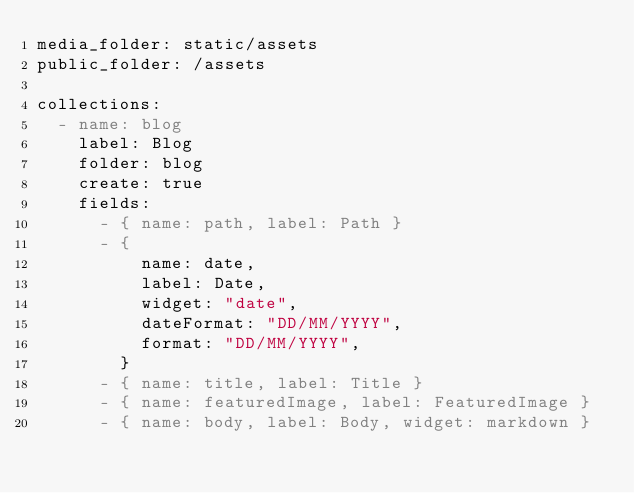<code> <loc_0><loc_0><loc_500><loc_500><_YAML_>media_folder: static/assets
public_folder: /assets

collections:
  - name: blog
    label: Blog
    folder: blog
    create: true
    fields:
      - { name: path, label: Path }
      - {
          name: date,
          label: Date,
          widget: "date",
          dateFormat: "DD/MM/YYYY",
          format: "DD/MM/YYYY",
        }
      - { name: title, label: Title }
      - { name: featuredImage, label: FeaturedImage }
      - { name: body, label: Body, widget: markdown }
</code> 